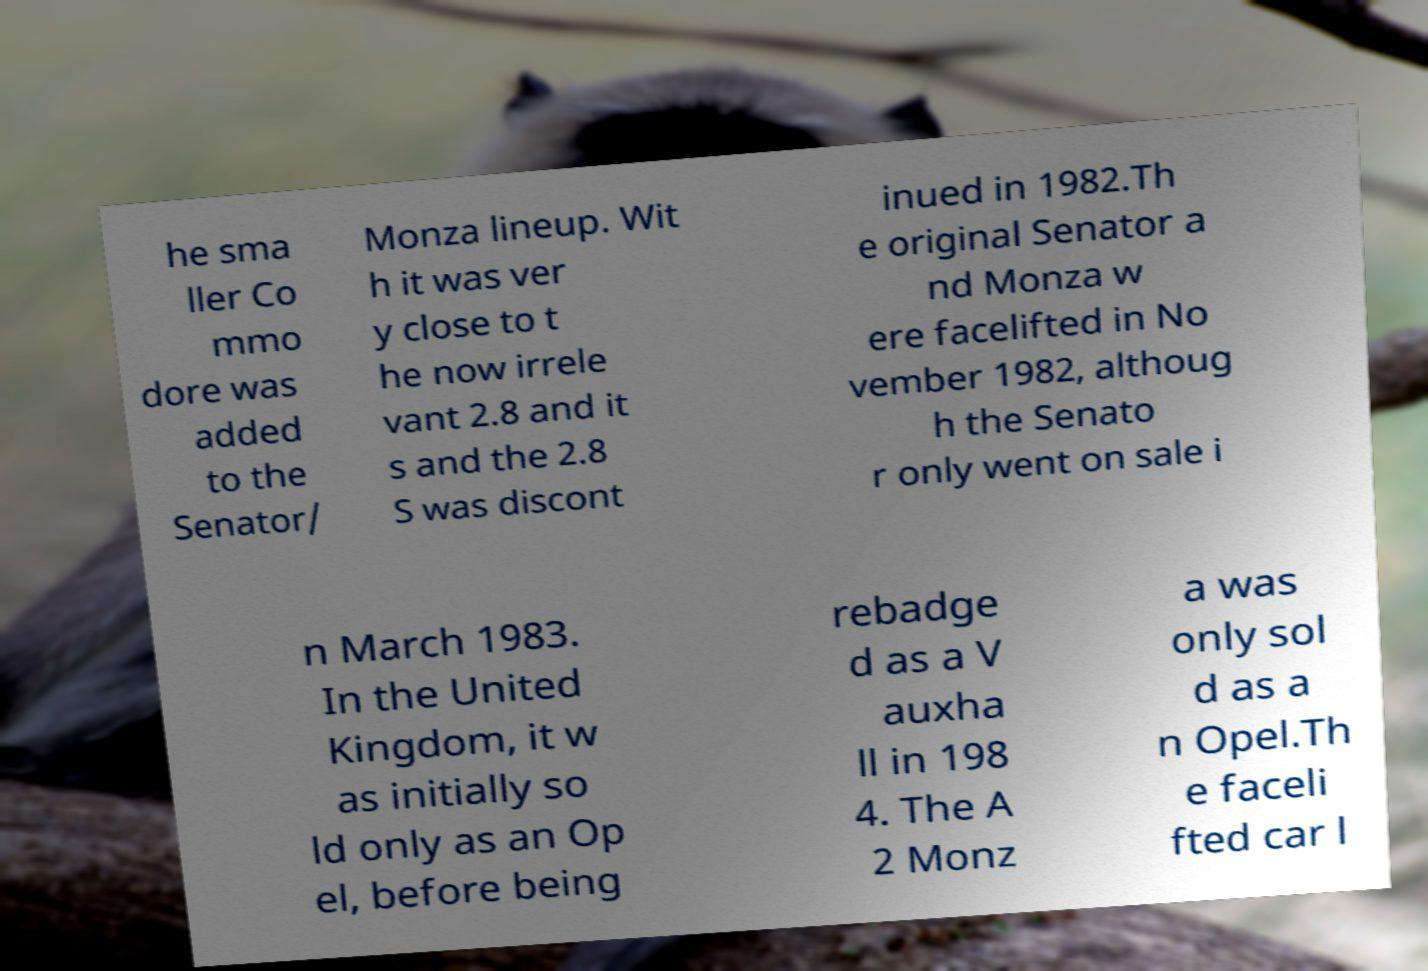Can you read and provide the text displayed in the image?This photo seems to have some interesting text. Can you extract and type it out for me? he sma ller Co mmo dore was added to the Senator/ Monza lineup. Wit h it was ver y close to t he now irrele vant 2.8 and it s and the 2.8 S was discont inued in 1982.Th e original Senator a nd Monza w ere facelifted in No vember 1982, althoug h the Senato r only went on sale i n March 1983. In the United Kingdom, it w as initially so ld only as an Op el, before being rebadge d as a V auxha ll in 198 4. The A 2 Monz a was only sol d as a n Opel.Th e faceli fted car l 